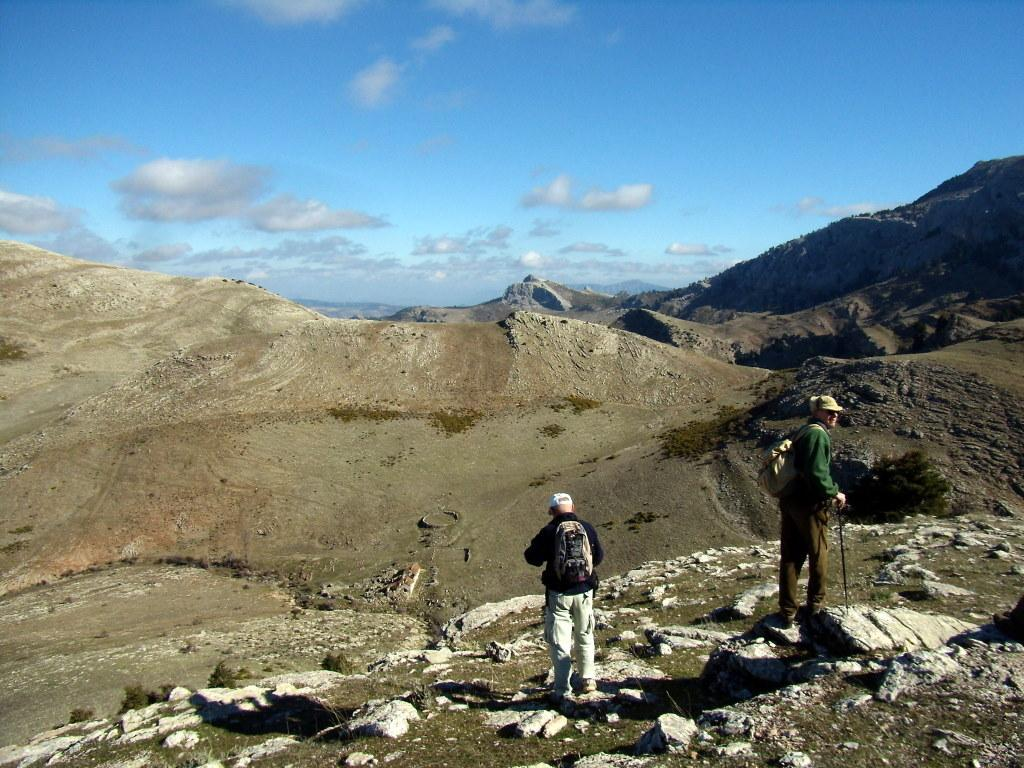What type of landscape can be seen in the image? There are hills in the image. What are the people in the image doing? The people in the image are carrying bags. What can be seen under the people's feet in the image? The ground is visible in the image. What type of natural objects can be seen on the ground in the image? There are stones in the image. What is visible above the hills in the image? The sky is visible in the image, and clouds are present in the sky. What type of lock is being used to secure the eggs in the image? There are no eggs or locks present in the image. What type of event is taking place in the image? There is no specific event taking place in the image; it simply shows hills, people carrying bags, stones, and a sky with clouds. 